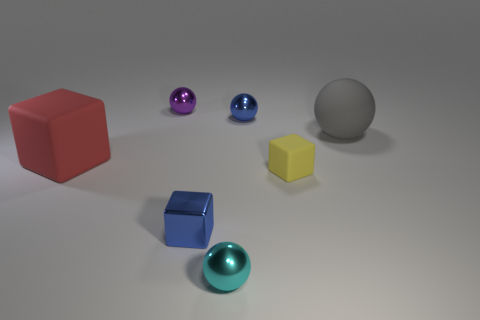Subtract 1 blocks. How many blocks are left? 2 Add 1 small purple spheres. How many objects exist? 8 Subtract all spheres. How many objects are left? 3 Subtract all large gray spheres. Subtract all red objects. How many objects are left? 5 Add 6 big matte objects. How many big matte objects are left? 8 Add 1 tiny blue rubber cubes. How many tiny blue rubber cubes exist? 1 Subtract 0 green cylinders. How many objects are left? 7 